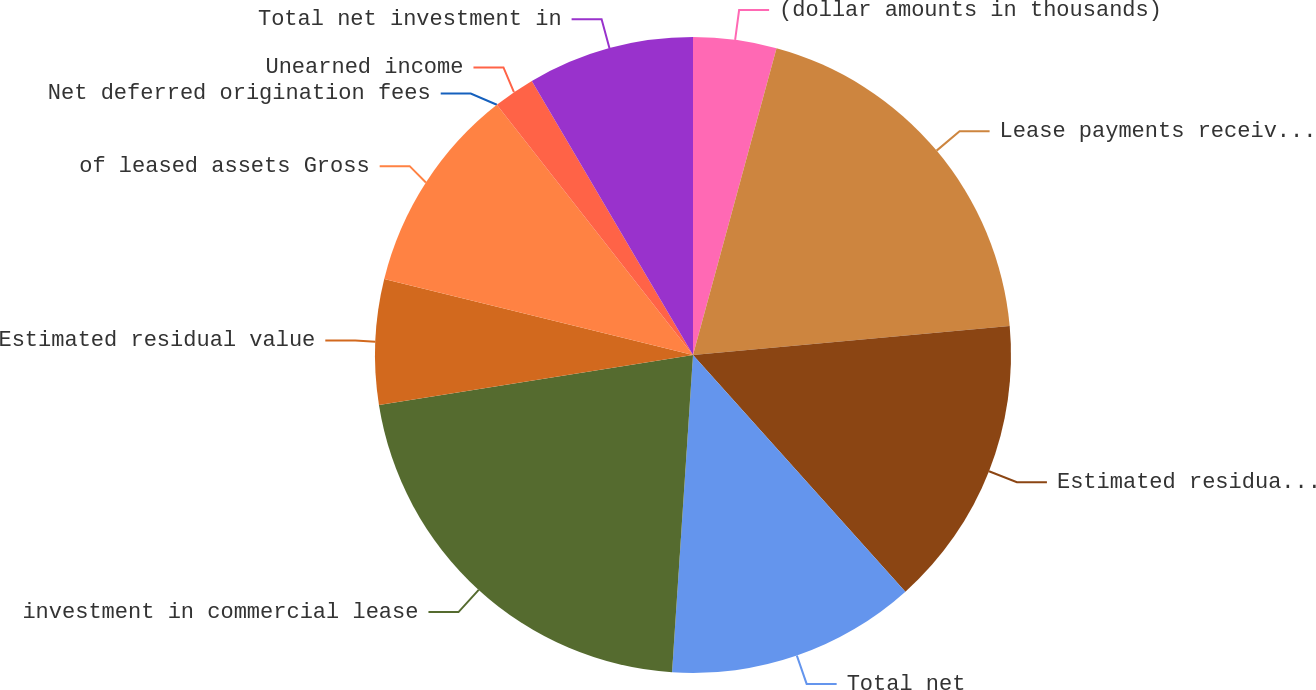<chart> <loc_0><loc_0><loc_500><loc_500><pie_chart><fcel>(dollar amounts in thousands)<fcel>Lease payments receivable<fcel>Estimated residual value of<fcel>Total net<fcel>investment in commercial lease<fcel>Estimated residual value<fcel>of leased assets Gross<fcel>Net deferred origination fees<fcel>Unearned income<fcel>Total net investment in<nl><fcel>4.23%<fcel>19.32%<fcel>14.81%<fcel>12.69%<fcel>21.44%<fcel>6.35%<fcel>10.58%<fcel>0.0%<fcel>2.12%<fcel>8.46%<nl></chart> 